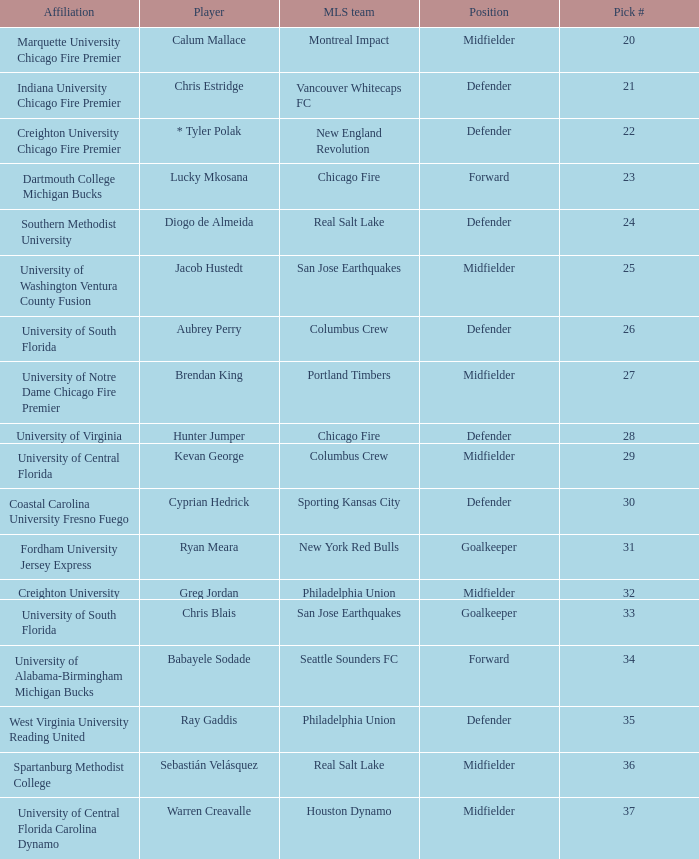What university was Kevan George affiliated with? University of Central Florida. I'm looking to parse the entire table for insights. Could you assist me with that? {'header': ['Affiliation', 'Player', 'MLS team', 'Position', 'Pick #'], 'rows': [['Marquette University Chicago Fire Premier', 'Calum Mallace', 'Montreal Impact', 'Midfielder', '20'], ['Indiana University Chicago Fire Premier', 'Chris Estridge', 'Vancouver Whitecaps FC', 'Defender', '21'], ['Creighton University Chicago Fire Premier', '* Tyler Polak', 'New England Revolution', 'Defender', '22'], ['Dartmouth College Michigan Bucks', 'Lucky Mkosana', 'Chicago Fire', 'Forward', '23'], ['Southern Methodist University', 'Diogo de Almeida', 'Real Salt Lake', 'Defender', '24'], ['University of Washington Ventura County Fusion', 'Jacob Hustedt', 'San Jose Earthquakes', 'Midfielder', '25'], ['University of South Florida', 'Aubrey Perry', 'Columbus Crew', 'Defender', '26'], ['University of Notre Dame Chicago Fire Premier', 'Brendan King', 'Portland Timbers', 'Midfielder', '27'], ['University of Virginia', 'Hunter Jumper', 'Chicago Fire', 'Defender', '28'], ['University of Central Florida', 'Kevan George', 'Columbus Crew', 'Midfielder', '29'], ['Coastal Carolina University Fresno Fuego', 'Cyprian Hedrick', 'Sporting Kansas City', 'Defender', '30'], ['Fordham University Jersey Express', 'Ryan Meara', 'New York Red Bulls', 'Goalkeeper', '31'], ['Creighton University', 'Greg Jordan', 'Philadelphia Union', 'Midfielder', '32'], ['University of South Florida', 'Chris Blais', 'San Jose Earthquakes', 'Goalkeeper', '33'], ['University of Alabama-Birmingham Michigan Bucks', 'Babayele Sodade', 'Seattle Sounders FC', 'Forward', '34'], ['West Virginia University Reading United', 'Ray Gaddis', 'Philadelphia Union', 'Defender', '35'], ['Spartanburg Methodist College', 'Sebastián Velásquez', 'Real Salt Lake', 'Midfielder', '36'], ['University of Central Florida Carolina Dynamo', 'Warren Creavalle', 'Houston Dynamo', 'Midfielder', '37']]} 